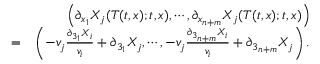<formula> <loc_0><loc_0><loc_500><loc_500>\begin{array} { r l r } & { \left ( \partial _ { x _ { 1 } } X _ { j } ( T ( t , x ) ; t , x ) , \cdots , \partial _ { x _ { n + m } } X _ { j } ( T ( t , x ) ; t , x ) \right ) } \\ & { = } & { \left ( - v _ { j } \frac { \partial _ { 3 _ { 1 } } X _ { i } } { v _ { i } } + \partial _ { 3 _ { 1 } } X _ { j } , \cdots , - v _ { j } \frac { \partial _ { 3 _ { n + m } } X _ { i } } { v _ { i } } + \partial _ { 3 _ { n + m } } X _ { j } \right ) . } \end{array}</formula> 